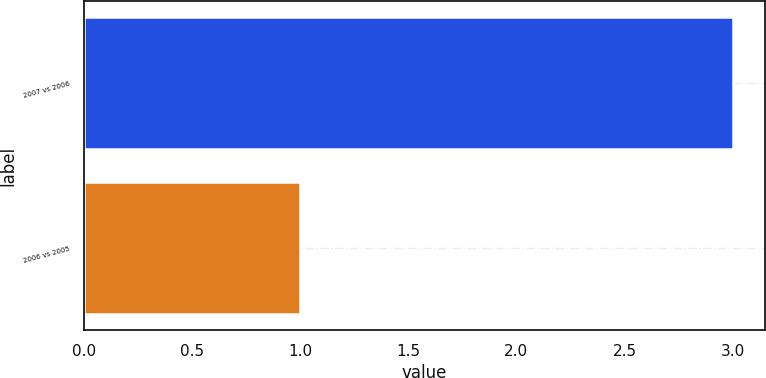Convert chart. <chart><loc_0><loc_0><loc_500><loc_500><bar_chart><fcel>2007 vs 2006<fcel>2006 vs 2005<nl><fcel>3<fcel>1<nl></chart> 